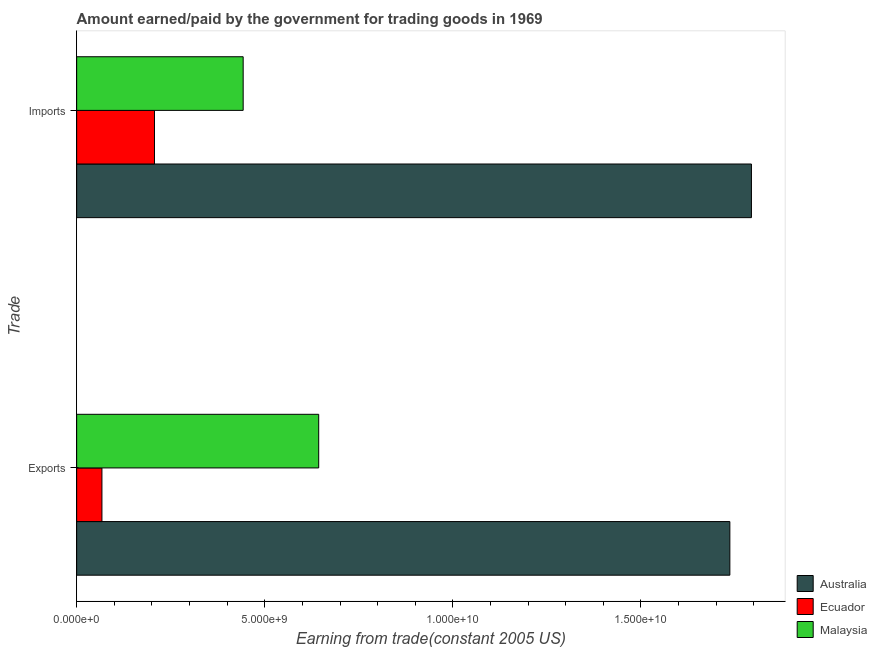How many different coloured bars are there?
Offer a terse response. 3. How many groups of bars are there?
Your response must be concise. 2. How many bars are there on the 1st tick from the top?
Provide a succinct answer. 3. What is the label of the 2nd group of bars from the top?
Make the answer very short. Exports. What is the amount paid for imports in Australia?
Your answer should be compact. 1.79e+1. Across all countries, what is the maximum amount earned from exports?
Your response must be concise. 1.74e+1. Across all countries, what is the minimum amount earned from exports?
Ensure brevity in your answer.  6.72e+08. In which country was the amount paid for imports minimum?
Your answer should be very brief. Ecuador. What is the total amount paid for imports in the graph?
Make the answer very short. 2.44e+1. What is the difference between the amount earned from exports in Australia and that in Ecuador?
Offer a terse response. 1.67e+1. What is the difference between the amount earned from exports in Australia and the amount paid for imports in Malaysia?
Make the answer very short. 1.29e+1. What is the average amount earned from exports per country?
Your response must be concise. 8.16e+09. What is the difference between the amount paid for imports and amount earned from exports in Australia?
Offer a terse response. 5.74e+08. In how many countries, is the amount paid for imports greater than 7000000000 US$?
Your response must be concise. 1. What is the ratio of the amount paid for imports in Malaysia to that in Ecuador?
Offer a terse response. 2.14. In how many countries, is the amount earned from exports greater than the average amount earned from exports taken over all countries?
Provide a short and direct response. 1. What does the 3rd bar from the top in Imports represents?
Your response must be concise. Australia. What does the 3rd bar from the bottom in Exports represents?
Make the answer very short. Malaysia. How many bars are there?
Keep it short and to the point. 6. What is the difference between two consecutive major ticks on the X-axis?
Your response must be concise. 5.00e+09. How many legend labels are there?
Provide a short and direct response. 3. How are the legend labels stacked?
Provide a succinct answer. Vertical. What is the title of the graph?
Provide a succinct answer. Amount earned/paid by the government for trading goods in 1969. Does "Lebanon" appear as one of the legend labels in the graph?
Keep it short and to the point. No. What is the label or title of the X-axis?
Your answer should be very brief. Earning from trade(constant 2005 US). What is the label or title of the Y-axis?
Ensure brevity in your answer.  Trade. What is the Earning from trade(constant 2005 US) of Australia in Exports?
Your answer should be compact. 1.74e+1. What is the Earning from trade(constant 2005 US) in Ecuador in Exports?
Your response must be concise. 6.72e+08. What is the Earning from trade(constant 2005 US) of Malaysia in Exports?
Give a very brief answer. 6.43e+09. What is the Earning from trade(constant 2005 US) in Australia in Imports?
Ensure brevity in your answer.  1.79e+1. What is the Earning from trade(constant 2005 US) in Ecuador in Imports?
Your response must be concise. 2.07e+09. What is the Earning from trade(constant 2005 US) of Malaysia in Imports?
Your response must be concise. 4.43e+09. Across all Trade, what is the maximum Earning from trade(constant 2005 US) of Australia?
Your answer should be very brief. 1.79e+1. Across all Trade, what is the maximum Earning from trade(constant 2005 US) of Ecuador?
Provide a short and direct response. 2.07e+09. Across all Trade, what is the maximum Earning from trade(constant 2005 US) of Malaysia?
Provide a short and direct response. 6.43e+09. Across all Trade, what is the minimum Earning from trade(constant 2005 US) in Australia?
Your answer should be very brief. 1.74e+1. Across all Trade, what is the minimum Earning from trade(constant 2005 US) of Ecuador?
Keep it short and to the point. 6.72e+08. Across all Trade, what is the minimum Earning from trade(constant 2005 US) of Malaysia?
Provide a short and direct response. 4.43e+09. What is the total Earning from trade(constant 2005 US) in Australia in the graph?
Offer a very short reply. 3.53e+1. What is the total Earning from trade(constant 2005 US) in Ecuador in the graph?
Offer a terse response. 2.74e+09. What is the total Earning from trade(constant 2005 US) in Malaysia in the graph?
Your answer should be compact. 1.09e+1. What is the difference between the Earning from trade(constant 2005 US) of Australia in Exports and that in Imports?
Give a very brief answer. -5.74e+08. What is the difference between the Earning from trade(constant 2005 US) in Ecuador in Exports and that in Imports?
Keep it short and to the point. -1.40e+09. What is the difference between the Earning from trade(constant 2005 US) in Malaysia in Exports and that in Imports?
Your answer should be very brief. 2.01e+09. What is the difference between the Earning from trade(constant 2005 US) in Australia in Exports and the Earning from trade(constant 2005 US) in Ecuador in Imports?
Give a very brief answer. 1.53e+1. What is the difference between the Earning from trade(constant 2005 US) of Australia in Exports and the Earning from trade(constant 2005 US) of Malaysia in Imports?
Make the answer very short. 1.29e+1. What is the difference between the Earning from trade(constant 2005 US) of Ecuador in Exports and the Earning from trade(constant 2005 US) of Malaysia in Imports?
Your response must be concise. -3.75e+09. What is the average Earning from trade(constant 2005 US) of Australia per Trade?
Offer a terse response. 1.76e+1. What is the average Earning from trade(constant 2005 US) in Ecuador per Trade?
Your answer should be compact. 1.37e+09. What is the average Earning from trade(constant 2005 US) of Malaysia per Trade?
Give a very brief answer. 5.43e+09. What is the difference between the Earning from trade(constant 2005 US) of Australia and Earning from trade(constant 2005 US) of Ecuador in Exports?
Your answer should be very brief. 1.67e+1. What is the difference between the Earning from trade(constant 2005 US) in Australia and Earning from trade(constant 2005 US) in Malaysia in Exports?
Provide a succinct answer. 1.09e+1. What is the difference between the Earning from trade(constant 2005 US) of Ecuador and Earning from trade(constant 2005 US) of Malaysia in Exports?
Ensure brevity in your answer.  -5.76e+09. What is the difference between the Earning from trade(constant 2005 US) of Australia and Earning from trade(constant 2005 US) of Ecuador in Imports?
Ensure brevity in your answer.  1.59e+1. What is the difference between the Earning from trade(constant 2005 US) of Australia and Earning from trade(constant 2005 US) of Malaysia in Imports?
Provide a succinct answer. 1.35e+1. What is the difference between the Earning from trade(constant 2005 US) in Ecuador and Earning from trade(constant 2005 US) in Malaysia in Imports?
Give a very brief answer. -2.36e+09. What is the ratio of the Earning from trade(constant 2005 US) in Ecuador in Exports to that in Imports?
Offer a terse response. 0.32. What is the ratio of the Earning from trade(constant 2005 US) of Malaysia in Exports to that in Imports?
Offer a very short reply. 1.45. What is the difference between the highest and the second highest Earning from trade(constant 2005 US) of Australia?
Keep it short and to the point. 5.74e+08. What is the difference between the highest and the second highest Earning from trade(constant 2005 US) of Ecuador?
Keep it short and to the point. 1.40e+09. What is the difference between the highest and the second highest Earning from trade(constant 2005 US) in Malaysia?
Give a very brief answer. 2.01e+09. What is the difference between the highest and the lowest Earning from trade(constant 2005 US) in Australia?
Your answer should be very brief. 5.74e+08. What is the difference between the highest and the lowest Earning from trade(constant 2005 US) of Ecuador?
Offer a very short reply. 1.40e+09. What is the difference between the highest and the lowest Earning from trade(constant 2005 US) in Malaysia?
Provide a short and direct response. 2.01e+09. 